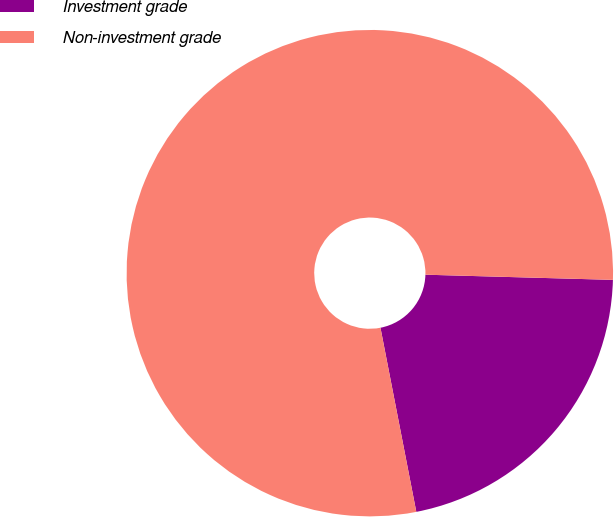Convert chart to OTSL. <chart><loc_0><loc_0><loc_500><loc_500><pie_chart><fcel>Investment grade<fcel>Non-investment grade<nl><fcel>21.5%<fcel>78.5%<nl></chart> 